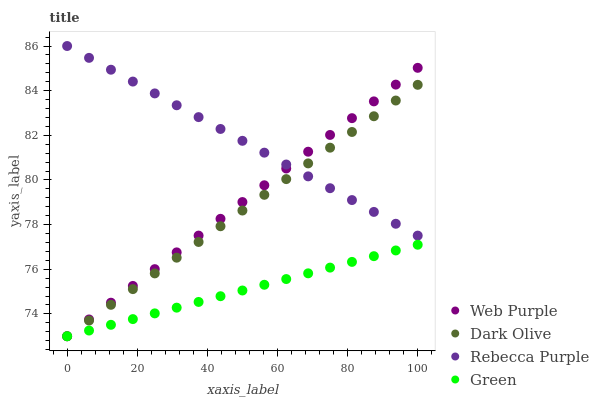Does Green have the minimum area under the curve?
Answer yes or no. Yes. Does Rebecca Purple have the maximum area under the curve?
Answer yes or no. Yes. Does Dark Olive have the minimum area under the curve?
Answer yes or no. No. Does Dark Olive have the maximum area under the curve?
Answer yes or no. No. Is Web Purple the smoothest?
Answer yes or no. Yes. Is Rebecca Purple the roughest?
Answer yes or no. Yes. Is Dark Olive the smoothest?
Answer yes or no. No. Is Dark Olive the roughest?
Answer yes or no. No. Does Web Purple have the lowest value?
Answer yes or no. Yes. Does Rebecca Purple have the lowest value?
Answer yes or no. No. Does Rebecca Purple have the highest value?
Answer yes or no. Yes. Does Dark Olive have the highest value?
Answer yes or no. No. Is Green less than Rebecca Purple?
Answer yes or no. Yes. Is Rebecca Purple greater than Green?
Answer yes or no. Yes. Does Green intersect Web Purple?
Answer yes or no. Yes. Is Green less than Web Purple?
Answer yes or no. No. Is Green greater than Web Purple?
Answer yes or no. No. Does Green intersect Rebecca Purple?
Answer yes or no. No. 